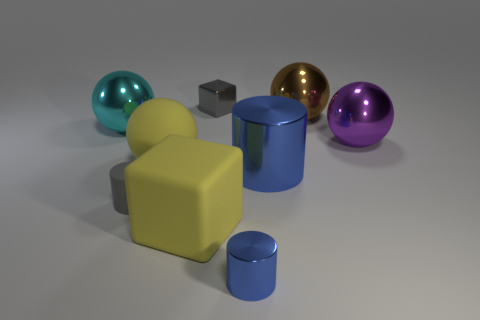There is a small matte object; is its color the same as the cube that is to the right of the big rubber block?
Your answer should be very brief. Yes. There is a metallic cube that is the same color as the small rubber object; what size is it?
Your answer should be compact. Small. Is there a gray matte sphere?
Offer a very short reply. No. There is another rubber thing that is the same shape as the large cyan thing; what is its color?
Provide a short and direct response. Yellow. There is a metal cylinder that is the same size as the purple metal sphere; what color is it?
Offer a very short reply. Blue. Is the purple object made of the same material as the brown object?
Your answer should be very brief. Yes. How many tiny shiny cylinders are the same color as the rubber sphere?
Your response must be concise. 0. Is the color of the matte cylinder the same as the metal cube?
Keep it short and to the point. Yes. What material is the tiny gray object that is in front of the big purple ball?
Ensure brevity in your answer.  Rubber. What number of big objects are blue metal things or yellow matte spheres?
Keep it short and to the point. 2. 